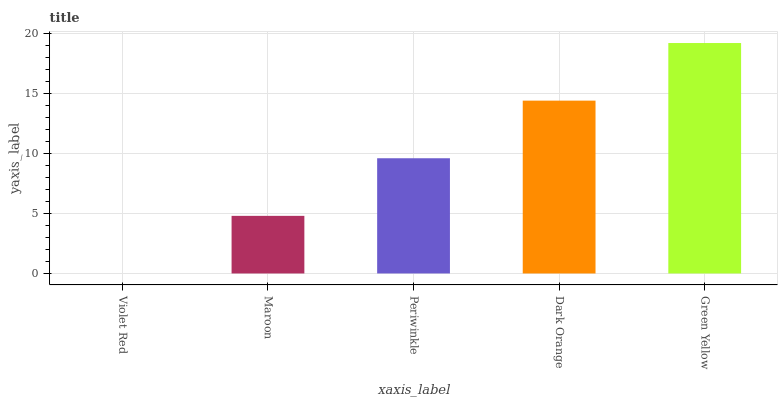Is Violet Red the minimum?
Answer yes or no. Yes. Is Green Yellow the maximum?
Answer yes or no. Yes. Is Maroon the minimum?
Answer yes or no. No. Is Maroon the maximum?
Answer yes or no. No. Is Maroon greater than Violet Red?
Answer yes or no. Yes. Is Violet Red less than Maroon?
Answer yes or no. Yes. Is Violet Red greater than Maroon?
Answer yes or no. No. Is Maroon less than Violet Red?
Answer yes or no. No. Is Periwinkle the high median?
Answer yes or no. Yes. Is Periwinkle the low median?
Answer yes or no. Yes. Is Dark Orange the high median?
Answer yes or no. No. Is Maroon the low median?
Answer yes or no. No. 